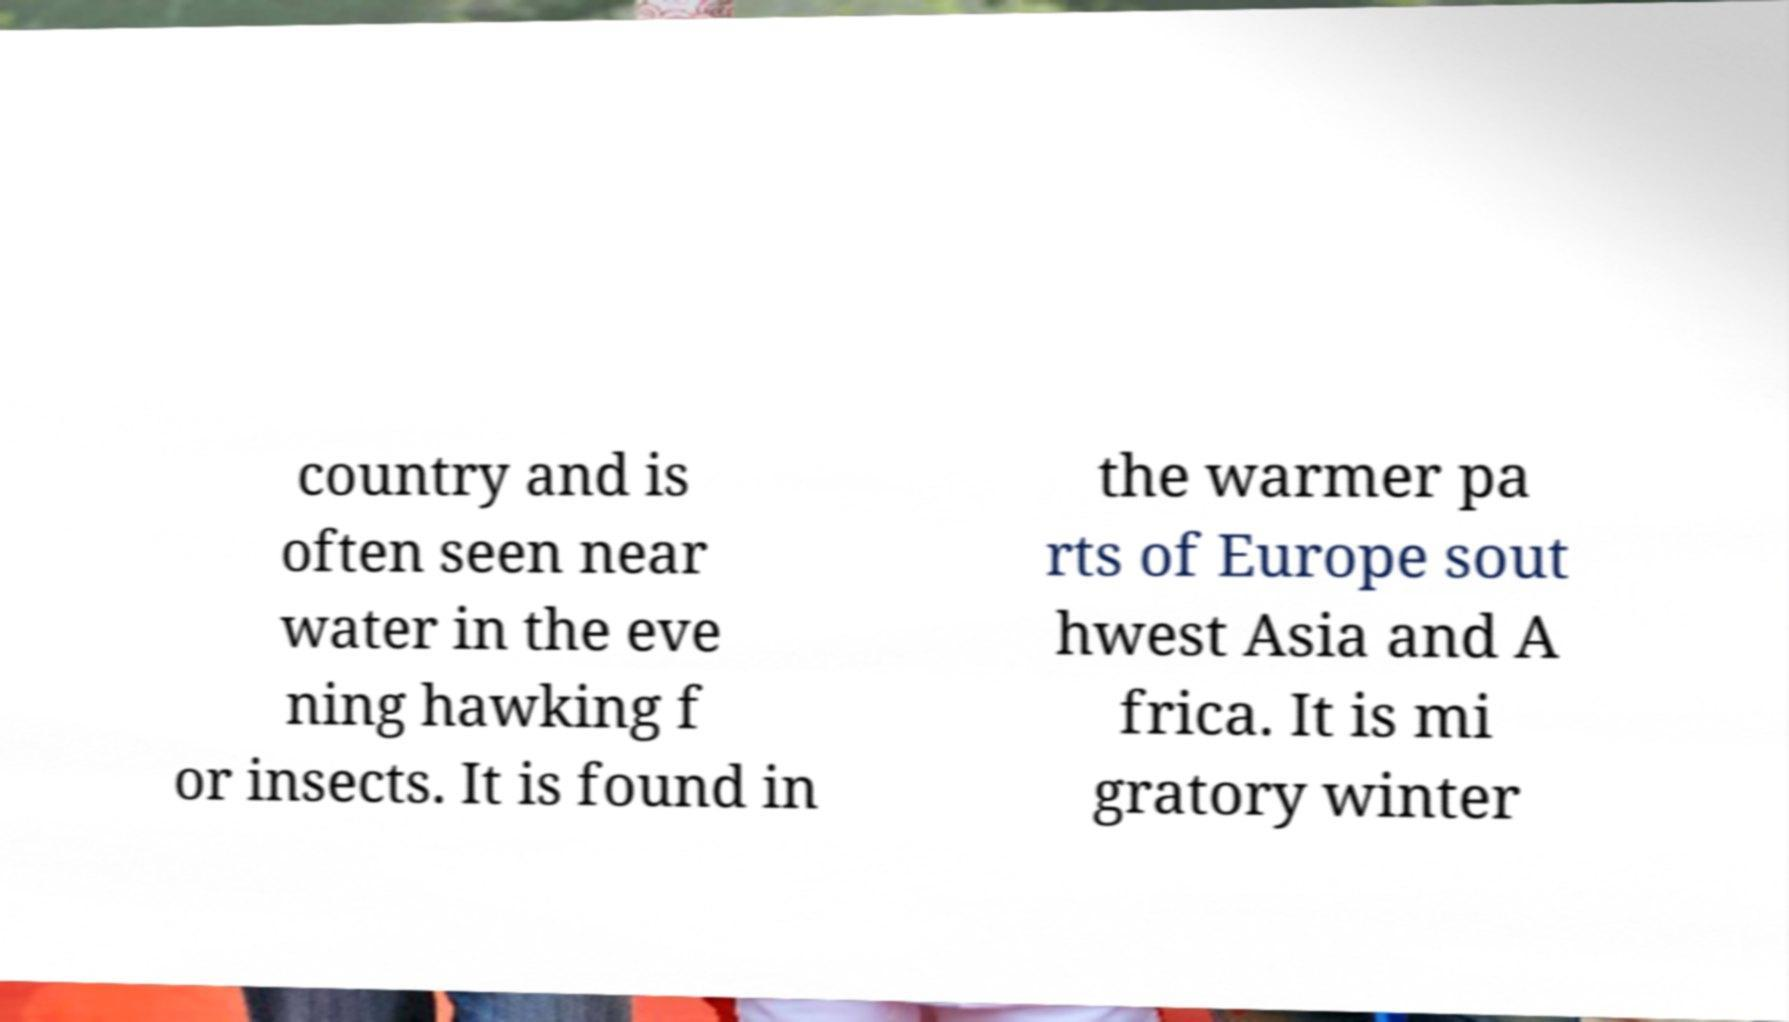Can you read and provide the text displayed in the image?This photo seems to have some interesting text. Can you extract and type it out for me? country and is often seen near water in the eve ning hawking f or insects. It is found in the warmer pa rts of Europe sout hwest Asia and A frica. It is mi gratory winter 